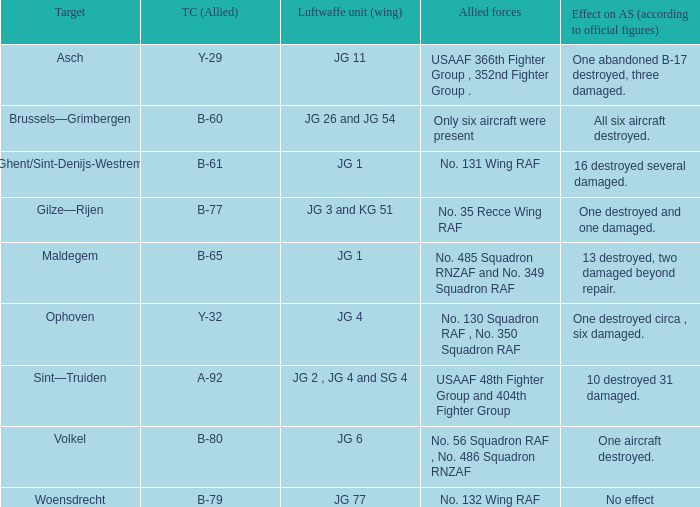Which Allied Force targetted Woensdrecht? No. 132 Wing RAF. 